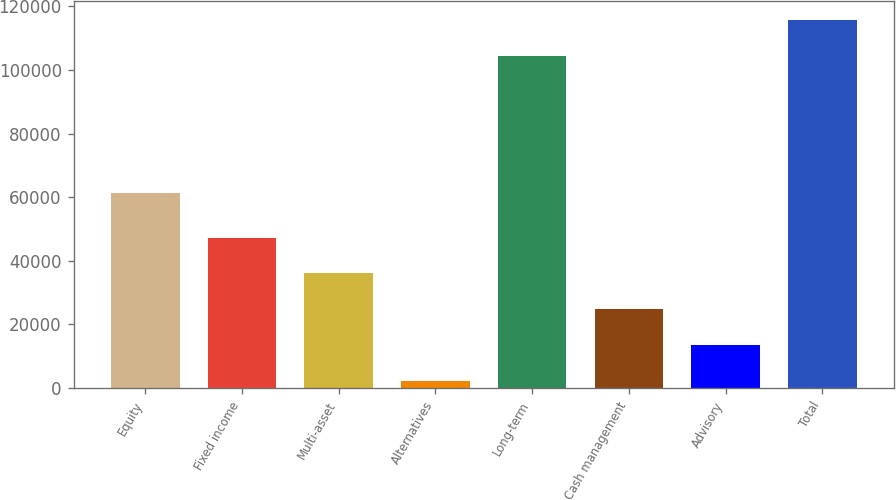Convert chart. <chart><loc_0><loc_0><loc_500><loc_500><bar_chart><fcel>Equity<fcel>Fixed income<fcel>Multi-asset<fcel>Alternatives<fcel>Long-term<fcel>Cash management<fcel>Advisory<fcel>Total<nl><fcel>61478<fcel>47312<fcel>36073<fcel>2356<fcel>104563<fcel>24834<fcel>13595<fcel>115802<nl></chart> 